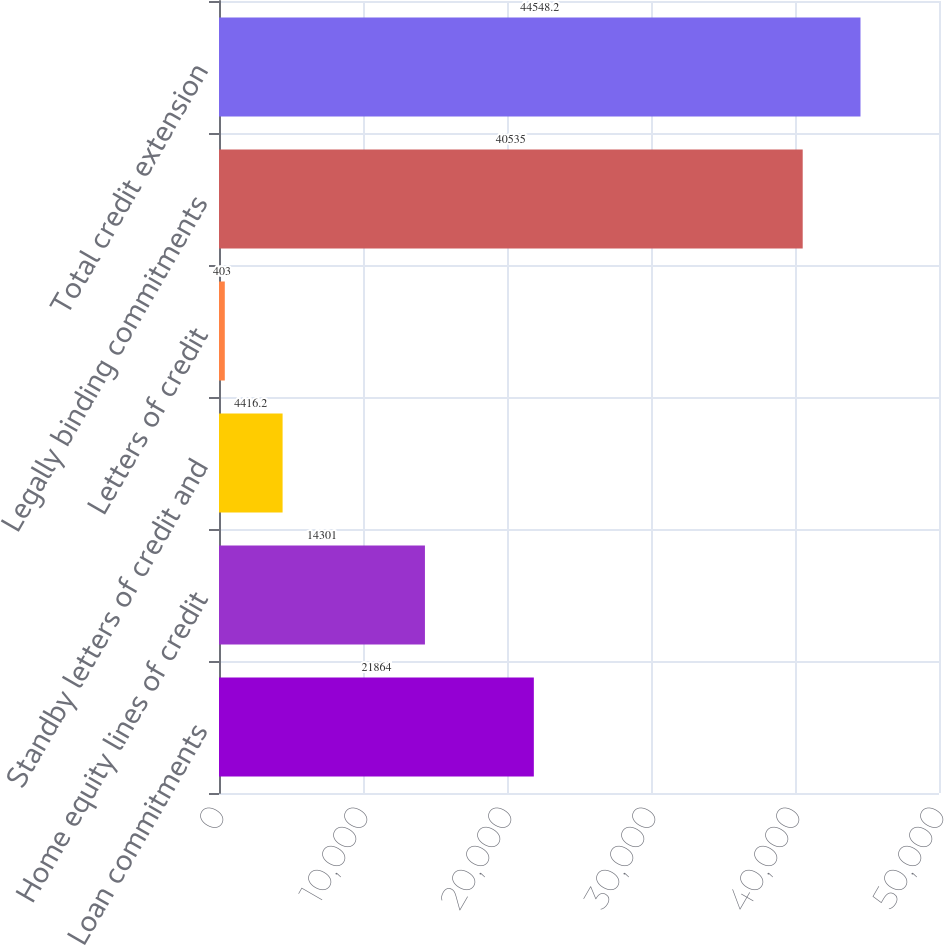Convert chart. <chart><loc_0><loc_0><loc_500><loc_500><bar_chart><fcel>Loan commitments<fcel>Home equity lines of credit<fcel>Standby letters of credit and<fcel>Letters of credit<fcel>Legally binding commitments<fcel>Total credit extension<nl><fcel>21864<fcel>14301<fcel>4416.2<fcel>403<fcel>40535<fcel>44548.2<nl></chart> 